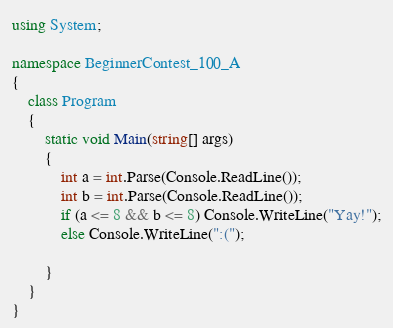<code> <loc_0><loc_0><loc_500><loc_500><_C#_>using System;

namespace BeginnerContest_100_A
{
    class Program
    {
        static void Main(string[] args)
        {
            int a = int.Parse(Console.ReadLine());
            int b = int.Parse(Console.ReadLine());
            if (a <= 8 && b <= 8) Console.WriteLine("Yay!");
            else Console.WriteLine(":(");
           
        }
    }
}
</code> 